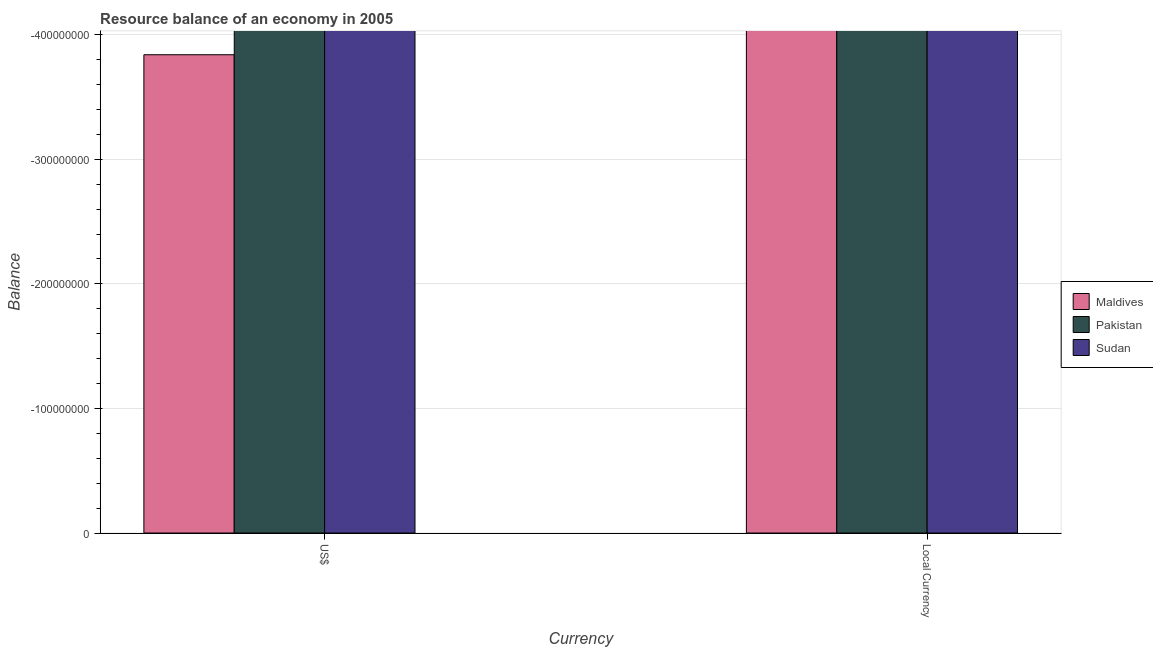How many different coloured bars are there?
Your answer should be compact. 0. How many bars are there on the 2nd tick from the right?
Make the answer very short. 0. What is the label of the 2nd group of bars from the left?
Keep it short and to the point. Local Currency. What is the resource balance in us$ in Pakistan?
Give a very brief answer. 0. What is the difference between the resource balance in us$ in Sudan and the resource balance in constant us$ in Pakistan?
Your response must be concise. 0. How many bars are there?
Keep it short and to the point. 0. Are all the bars in the graph horizontal?
Give a very brief answer. No. What is the difference between two consecutive major ticks on the Y-axis?
Ensure brevity in your answer.  1.00e+08. Are the values on the major ticks of Y-axis written in scientific E-notation?
Ensure brevity in your answer.  No. Does the graph contain any zero values?
Your answer should be very brief. Yes. Does the graph contain grids?
Give a very brief answer. Yes. How many legend labels are there?
Provide a short and direct response. 3. What is the title of the graph?
Offer a very short reply. Resource balance of an economy in 2005. Does "American Samoa" appear as one of the legend labels in the graph?
Provide a short and direct response. No. What is the label or title of the X-axis?
Offer a very short reply. Currency. What is the label or title of the Y-axis?
Your response must be concise. Balance. What is the Balance in Sudan in US$?
Provide a short and direct response. 0. What is the Balance in Sudan in Local Currency?
Your answer should be compact. 0. What is the total Balance in Maldives in the graph?
Your response must be concise. 0. What is the total Balance of Sudan in the graph?
Provide a short and direct response. 0. What is the average Balance in Maldives per Currency?
Offer a terse response. 0. 